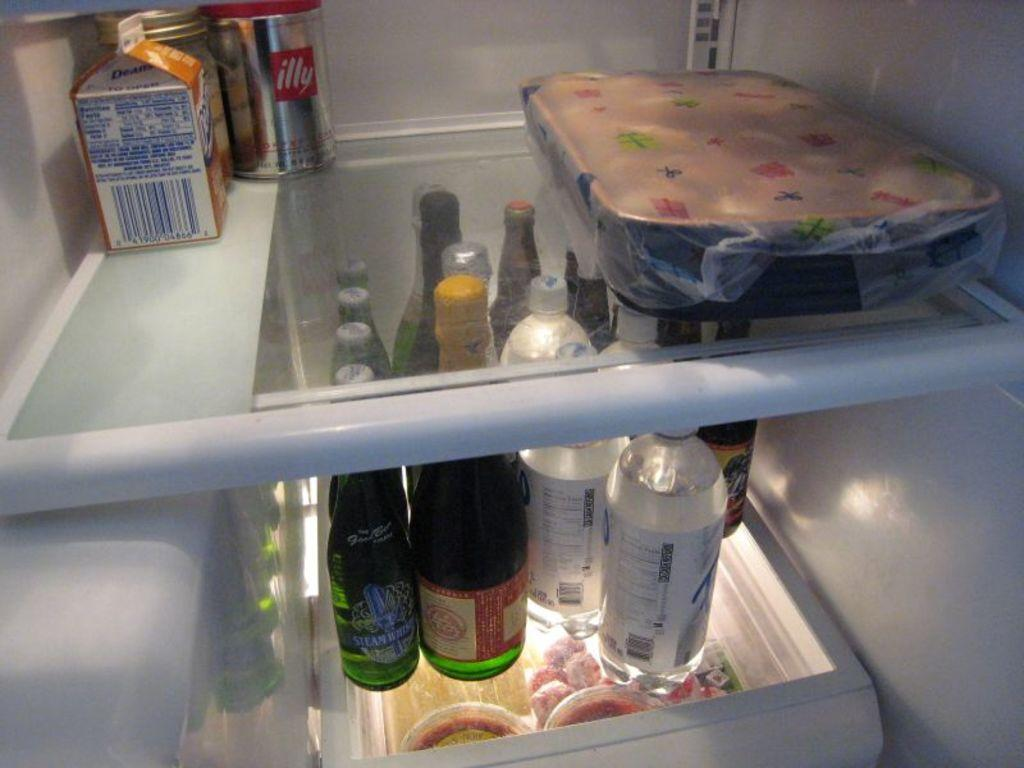<image>
Provide a brief description of the given image. A can that says illy has been pushed to the very back of the fridge. 